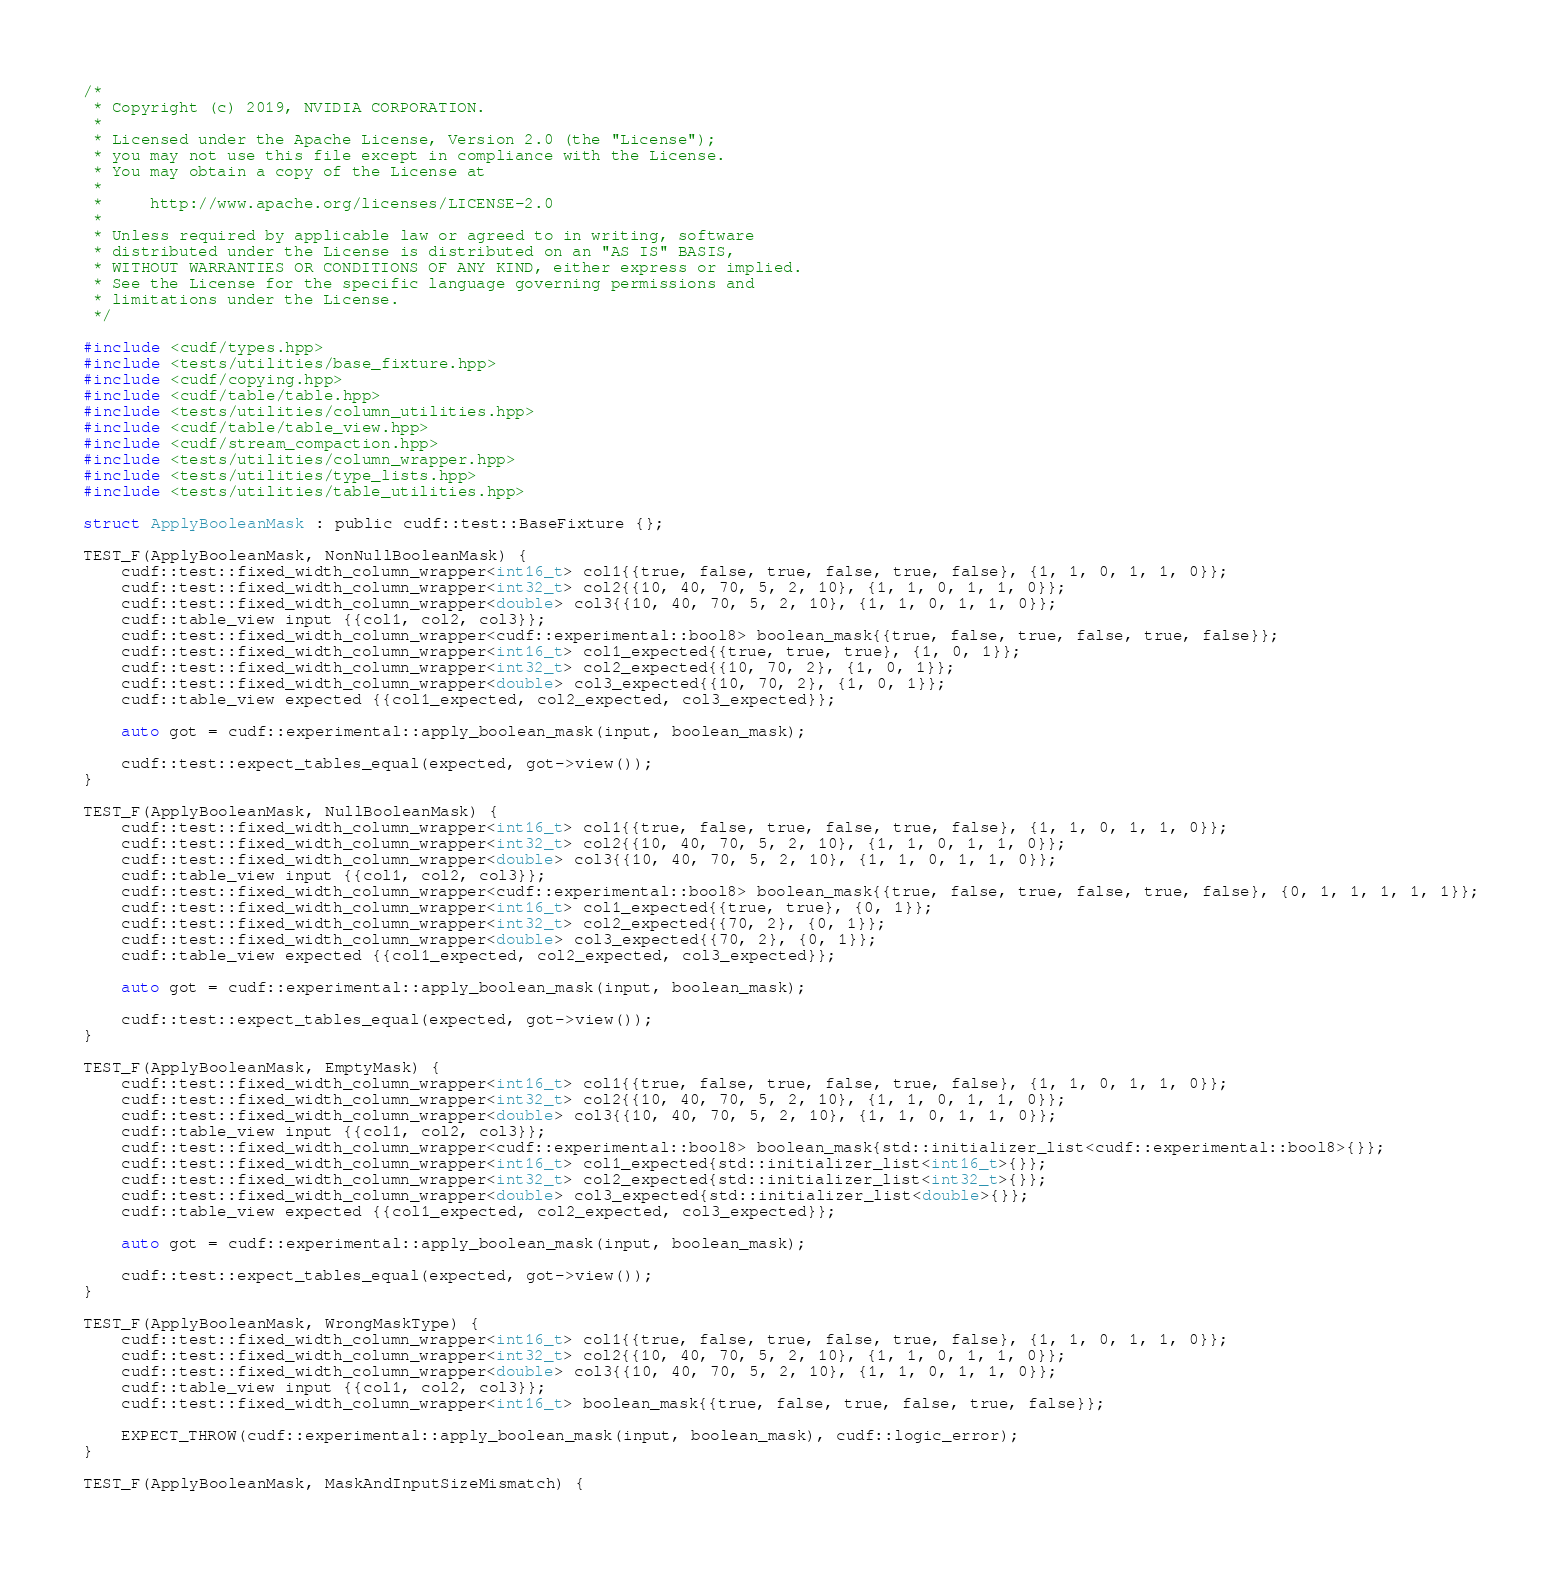Convert code to text. <code><loc_0><loc_0><loc_500><loc_500><_Cuda_>/*
 * Copyright (c) 2019, NVIDIA CORPORATION.
 *
 * Licensed under the Apache License, Version 2.0 (the "License");
 * you may not use this file except in compliance with the License.
 * You may obtain a copy of the License at
 *
 *     http://www.apache.org/licenses/LICENSE-2.0
 *
 * Unless required by applicable law or agreed to in writing, software
 * distributed under the License is distributed on an "AS IS" BASIS,
 * WITHOUT WARRANTIES OR CONDITIONS OF ANY KIND, either express or implied.
 * See the License for the specific language governing permissions and
 * limitations under the License.
 */

#include <cudf/types.hpp>
#include <tests/utilities/base_fixture.hpp>
#include <cudf/copying.hpp>
#include <cudf/table/table.hpp>
#include <tests/utilities/column_utilities.hpp>
#include <cudf/table/table_view.hpp>
#include <cudf/stream_compaction.hpp>
#include <tests/utilities/column_wrapper.hpp>
#include <tests/utilities/type_lists.hpp>
#include <tests/utilities/table_utilities.hpp>

struct ApplyBooleanMask : public cudf::test::BaseFixture {};

TEST_F(ApplyBooleanMask, NonNullBooleanMask) {
    cudf::test::fixed_width_column_wrapper<int16_t> col1{{true, false, true, false, true, false}, {1, 1, 0, 1, 1, 0}};
    cudf::test::fixed_width_column_wrapper<int32_t> col2{{10, 40, 70, 5, 2, 10}, {1, 1, 0, 1, 1, 0}};
    cudf::test::fixed_width_column_wrapper<double> col3{{10, 40, 70, 5, 2, 10}, {1, 1, 0, 1, 1, 0}};
    cudf::table_view input {{col1, col2, col3}};
    cudf::test::fixed_width_column_wrapper<cudf::experimental::bool8> boolean_mask{{true, false, true, false, true, false}};
    cudf::test::fixed_width_column_wrapper<int16_t> col1_expected{{true, true, true}, {1, 0, 1}};
    cudf::test::fixed_width_column_wrapper<int32_t> col2_expected{{10, 70, 2}, {1, 0, 1}};
    cudf::test::fixed_width_column_wrapper<double> col3_expected{{10, 70, 2}, {1, 0, 1}};
    cudf::table_view expected {{col1_expected, col2_expected, col3_expected}};

    auto got = cudf::experimental::apply_boolean_mask(input, boolean_mask);

    cudf::test::expect_tables_equal(expected, got->view());
}

TEST_F(ApplyBooleanMask, NullBooleanMask) {
    cudf::test::fixed_width_column_wrapper<int16_t> col1{{true, false, true, false, true, false}, {1, 1, 0, 1, 1, 0}};
    cudf::test::fixed_width_column_wrapper<int32_t> col2{{10, 40, 70, 5, 2, 10}, {1, 1, 0, 1, 1, 0}};
    cudf::test::fixed_width_column_wrapper<double> col3{{10, 40, 70, 5, 2, 10}, {1, 1, 0, 1, 1, 0}};
    cudf::table_view input {{col1, col2, col3}};
    cudf::test::fixed_width_column_wrapper<cudf::experimental::bool8> boolean_mask{{true, false, true, false, true, false}, {0, 1, 1, 1, 1, 1}};
    cudf::test::fixed_width_column_wrapper<int16_t> col1_expected{{true, true}, {0, 1}};
    cudf::test::fixed_width_column_wrapper<int32_t> col2_expected{{70, 2}, {0, 1}};
    cudf::test::fixed_width_column_wrapper<double> col3_expected{{70, 2}, {0, 1}};
    cudf::table_view expected {{col1_expected, col2_expected, col3_expected}};

    auto got = cudf::experimental::apply_boolean_mask(input, boolean_mask);

    cudf::test::expect_tables_equal(expected, got->view());
}

TEST_F(ApplyBooleanMask, EmptyMask) {
    cudf::test::fixed_width_column_wrapper<int16_t> col1{{true, false, true, false, true, false}, {1, 1, 0, 1, 1, 0}};
    cudf::test::fixed_width_column_wrapper<int32_t> col2{{10, 40, 70, 5, 2, 10}, {1, 1, 0, 1, 1, 0}};
    cudf::test::fixed_width_column_wrapper<double> col3{{10, 40, 70, 5, 2, 10}, {1, 1, 0, 1, 1, 0}};
    cudf::table_view input {{col1, col2, col3}};
    cudf::test::fixed_width_column_wrapper<cudf::experimental::bool8> boolean_mask{std::initializer_list<cudf::experimental::bool8>{}};
    cudf::test::fixed_width_column_wrapper<int16_t> col1_expected{std::initializer_list<int16_t>{}};
    cudf::test::fixed_width_column_wrapper<int32_t> col2_expected{std::initializer_list<int32_t>{}};
    cudf::test::fixed_width_column_wrapper<double> col3_expected{std::initializer_list<double>{}};
    cudf::table_view expected {{col1_expected, col2_expected, col3_expected}};

    auto got = cudf::experimental::apply_boolean_mask(input, boolean_mask);

    cudf::test::expect_tables_equal(expected, got->view());
}

TEST_F(ApplyBooleanMask, WrongMaskType) {
    cudf::test::fixed_width_column_wrapper<int16_t> col1{{true, false, true, false, true, false}, {1, 1, 0, 1, 1, 0}};
    cudf::test::fixed_width_column_wrapper<int32_t> col2{{10, 40, 70, 5, 2, 10}, {1, 1, 0, 1, 1, 0}};
    cudf::test::fixed_width_column_wrapper<double> col3{{10, 40, 70, 5, 2, 10}, {1, 1, 0, 1, 1, 0}};
    cudf::table_view input {{col1, col2, col3}};
    cudf::test::fixed_width_column_wrapper<int16_t> boolean_mask{{true, false, true, false, true, false}};

    EXPECT_THROW(cudf::experimental::apply_boolean_mask(input, boolean_mask), cudf::logic_error);
}

TEST_F(ApplyBooleanMask, MaskAndInputSizeMismatch) {</code> 